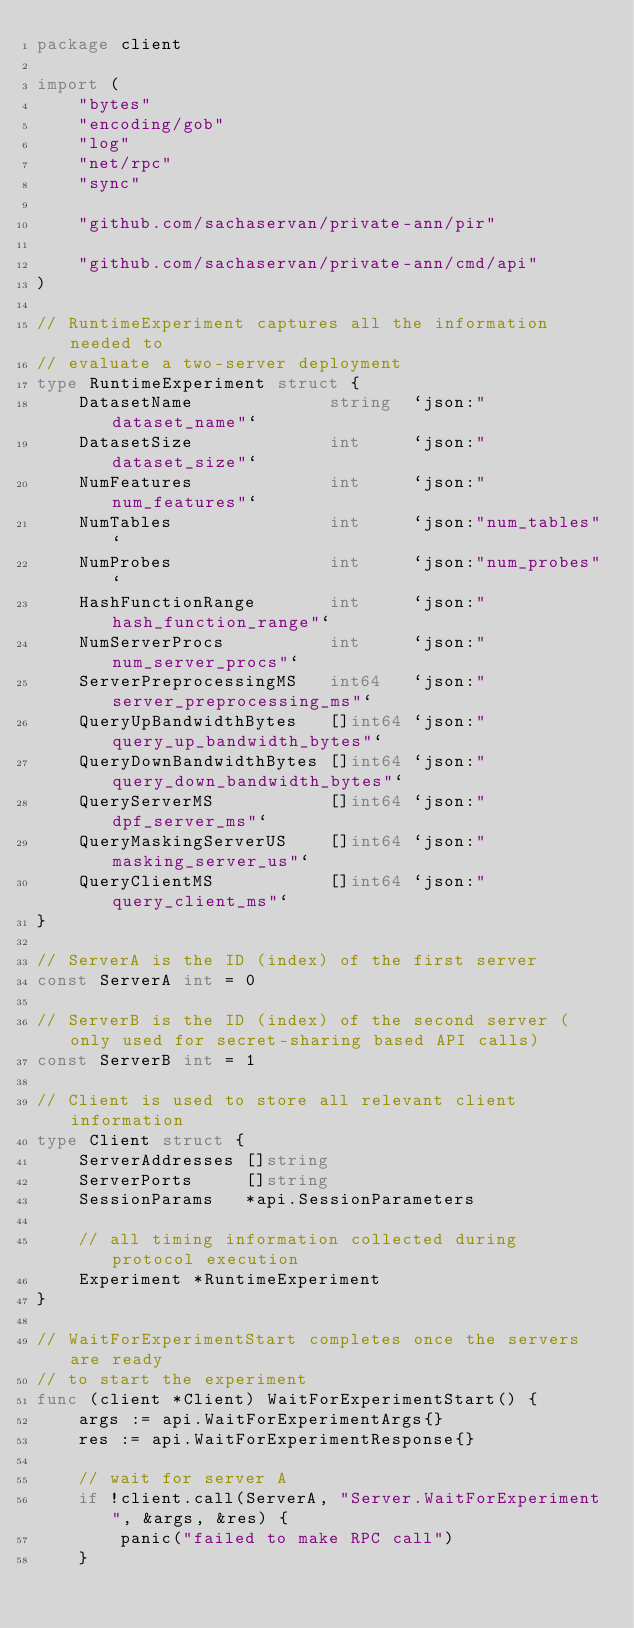Convert code to text. <code><loc_0><loc_0><loc_500><loc_500><_Go_>package client

import (
	"bytes"
	"encoding/gob"
	"log"
	"net/rpc"
	"sync"

	"github.com/sachaservan/private-ann/pir"

	"github.com/sachaservan/private-ann/cmd/api"
)

// RuntimeExperiment captures all the information needed to
// evaluate a two-server deployment
type RuntimeExperiment struct {
	DatasetName             string  `json:"dataset_name"`
	DatasetSize             int     `json:"dataset_size"`
	NumFeatures             int     `json:"num_features"`
	NumTables               int     `json:"num_tables"`
	NumProbes               int     `json:"num_probes"`
	HashFunctionRange       int     `json:"hash_function_range"`
	NumServerProcs          int     `json:"num_server_procs"`
	ServerPreprocessingMS   int64   `json:"server_preprocessing_ms"`
	QueryUpBandwidthBytes   []int64 `json:"query_up_bandwidth_bytes"`
	QueryDownBandwidthBytes []int64 `json:"query_down_bandwidth_bytes"`
	QueryServerMS           []int64 `json:"dpf_server_ms"`
	QueryMaskingServerUS    []int64 `json:"masking_server_us"`
	QueryClientMS           []int64 `json:"query_client_ms"`
}

// ServerA is the ID (index) of the first server
const ServerA int = 0

// ServerB is the ID (index) of the second server (only used for secret-sharing based API calls)
const ServerB int = 1

// Client is used to store all relevant client information
type Client struct {
	ServerAddresses []string
	ServerPorts     []string
	SessionParams   *api.SessionParameters

	// all timing information collected during protocol execution
	Experiment *RuntimeExperiment
}

// WaitForExperimentStart completes once the servers are ready
// to start the experiment
func (client *Client) WaitForExperimentStart() {
	args := api.WaitForExperimentArgs{}
	res := api.WaitForExperimentResponse{}

	// wait for server A
	if !client.call(ServerA, "Server.WaitForExperiment", &args, &res) {
		panic("failed to make RPC call")
	}
</code> 